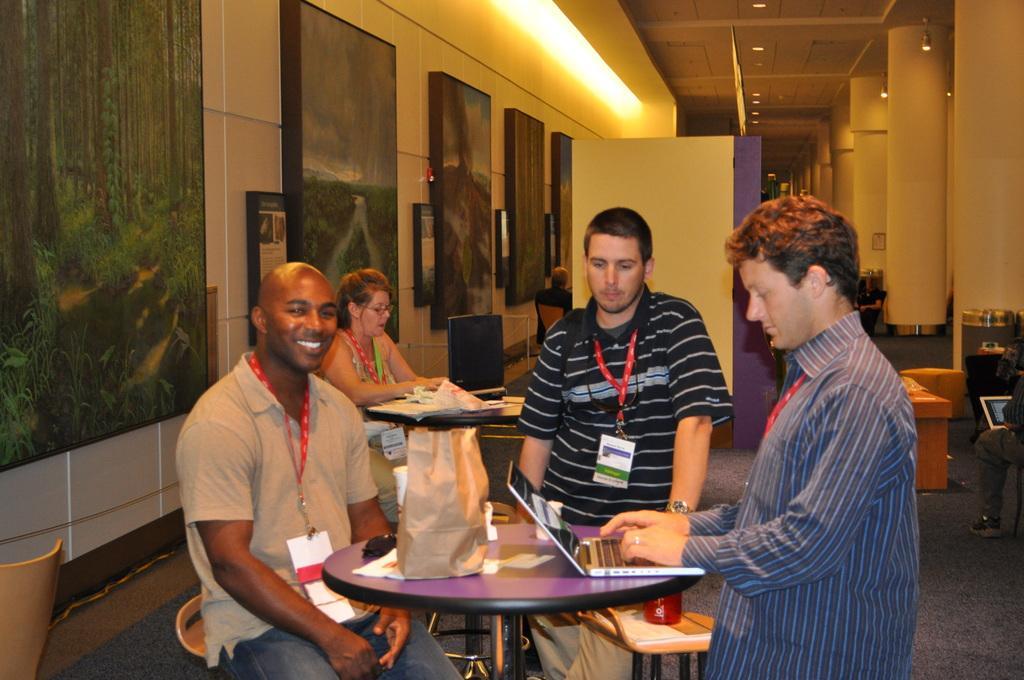How would you summarize this image in a sentence or two? As we can see in the image there is a wall, photo frames and few people sitting on chairs and there is a table. On table there is a cover and laptop. 